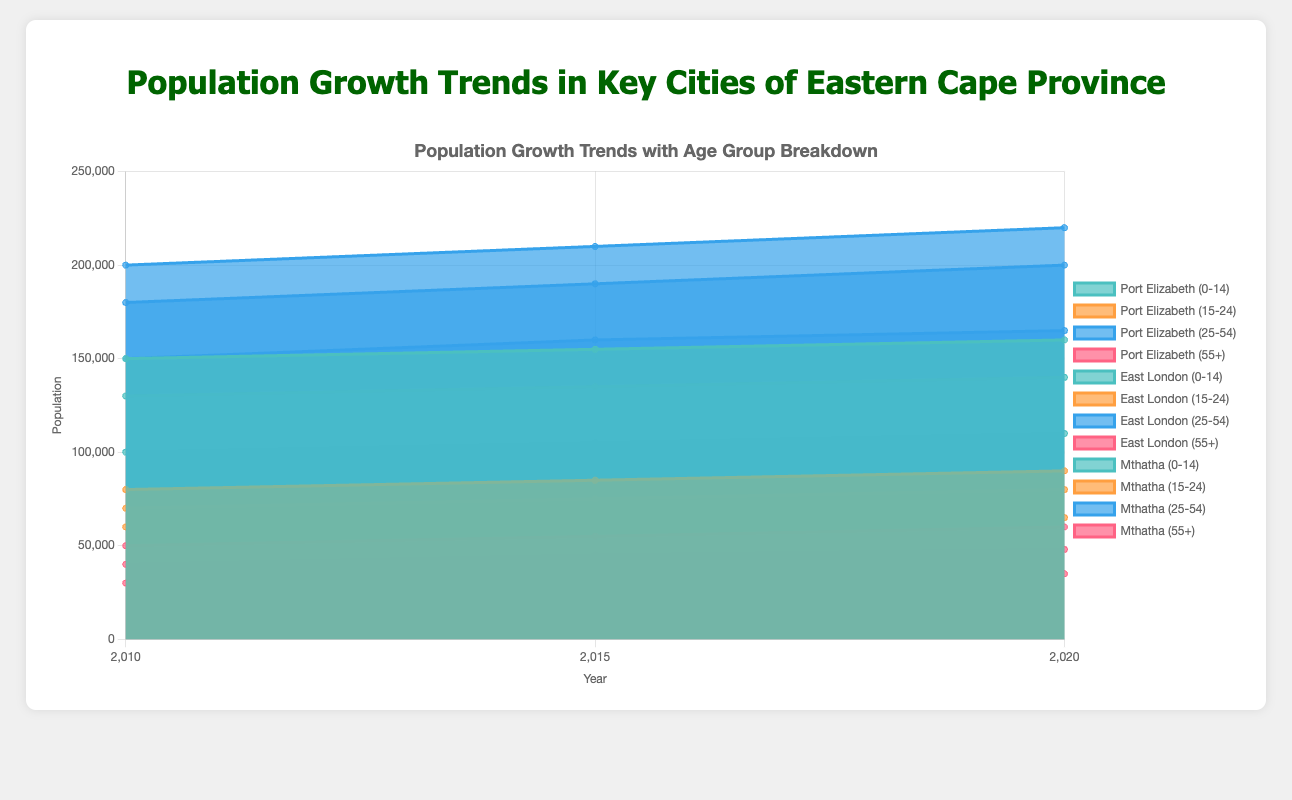What's the title of the chart? The title of the chart is displayed at the top, which reads "Population Growth Trends with Age Group Breakdown".
Answer: Population Growth Trends with Age Group Breakdown Which age group in Port Elizabeth shows the largest population increase from 2010 to 2020? By comparing the population data for each age group in Port Elizabeth from 2010 to 2020, we see that the 25-54 age group increases from 200,000 to 220,000, which is the largest numeric increase of 20,000 people.
Answer: 25-54 In East London, how does the population of the 0-14 age group in 2020 compare to the 25-54 age group in 2015? In 2020, the population for the 0-14 age group in East London is 140,000. In 2015, the population for the 25-54 age group in East London is 190,000. Therefore, the 25-54 age group in 2015 has a higher population.
Answer: 25-54 age group in 2015 has a higher population What is the combined population of the 15-24 and 55+ age groups in Mthatha in 2015? The population for the 15-24 age group in Mthatha in 2015 is 62,000, and the population for the 55+ age group is 32,000. Adding these together, the combined population is 62,000 + 32,000 = 94,000.
Answer: 94,000 Which city shows the smallest increase in population for the 0-14 age group from 2010 to 2020? By examining the 0-14 age group data for each city from 2010 to 2020: Port Elizabeth increases by 10,000 (150,000 to 160,000), East London by 10,000 (130,000 to 140,000), and Mthatha by 10,000 (100,000 to 110,000). All cities show the same increase of 10,000.
Answer: All cities show the same increase How does the population trend for the 55+ age group in Port Elizabeth compare to the trend in East London from 2010 to 2020? From 2010 to 2020, the 55+ age group in Port Elizabeth increases from 50,000 to 60,000, an increase of 10,000. In East London, the same age group increases from 40,000 to 48,000, an increase of 8,000. Port Elizabeth has a larger increase.
Answer: Port Elizabeth has a larger increase What is the average population of the 0-14 age group in Mthatha across the three years provided? The populations for the 0-14 age group in Mthatha are 100,000 in 2010, 105,000 in 2015, and 110,000 in 2020. The average population is calculated as (100,000 + 105,000 + 110,000) / 3 = 315,000 / 3 = 105,000.
Answer: 105,000 Which city has the highest population for the 25-54 age group in 2020? By comparing the 2020 population data for the 25-54 age group: Port Elizabeth has 220,000, East London has 200,000, and Mthatha has 165,000. Port Elizabeth has the highest population for this age group.
Answer: Port Elizabeth How does the population growth trend for the 15-24 age group in Mthatha differ from the same age group in East London from 2010 to 2020? From 2010 to 2020, the population for the 15-24 age group in Mthatha increased from 60,000 to 65,000, an increase of 5,000. In East London, the increase is from 70,000 to 80,000, an increase of 10,000. Thus, East London has a larger increase.
Answer: East London has a larger increase 